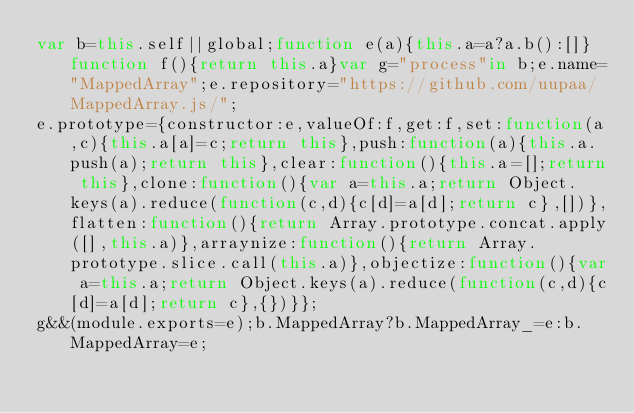<code> <loc_0><loc_0><loc_500><loc_500><_JavaScript_>var b=this.self||global;function e(a){this.a=a?a.b():[]}function f(){return this.a}var g="process"in b;e.name="MappedArray";e.repository="https://github.com/uupaa/MappedArray.js/";
e.prototype={constructor:e,valueOf:f,get:f,set:function(a,c){this.a[a]=c;return this},push:function(a){this.a.push(a);return this},clear:function(){this.a=[];return this},clone:function(){var a=this.a;return Object.keys(a).reduce(function(c,d){c[d]=a[d];return c},[])},flatten:function(){return Array.prototype.concat.apply([],this.a)},arraynize:function(){return Array.prototype.slice.call(this.a)},objectize:function(){var a=this.a;return Object.keys(a).reduce(function(c,d){c[d]=a[d];return c},{})}};
g&&(module.exports=e);b.MappedArray?b.MappedArray_=e:b.MappedArray=e;
</code> 